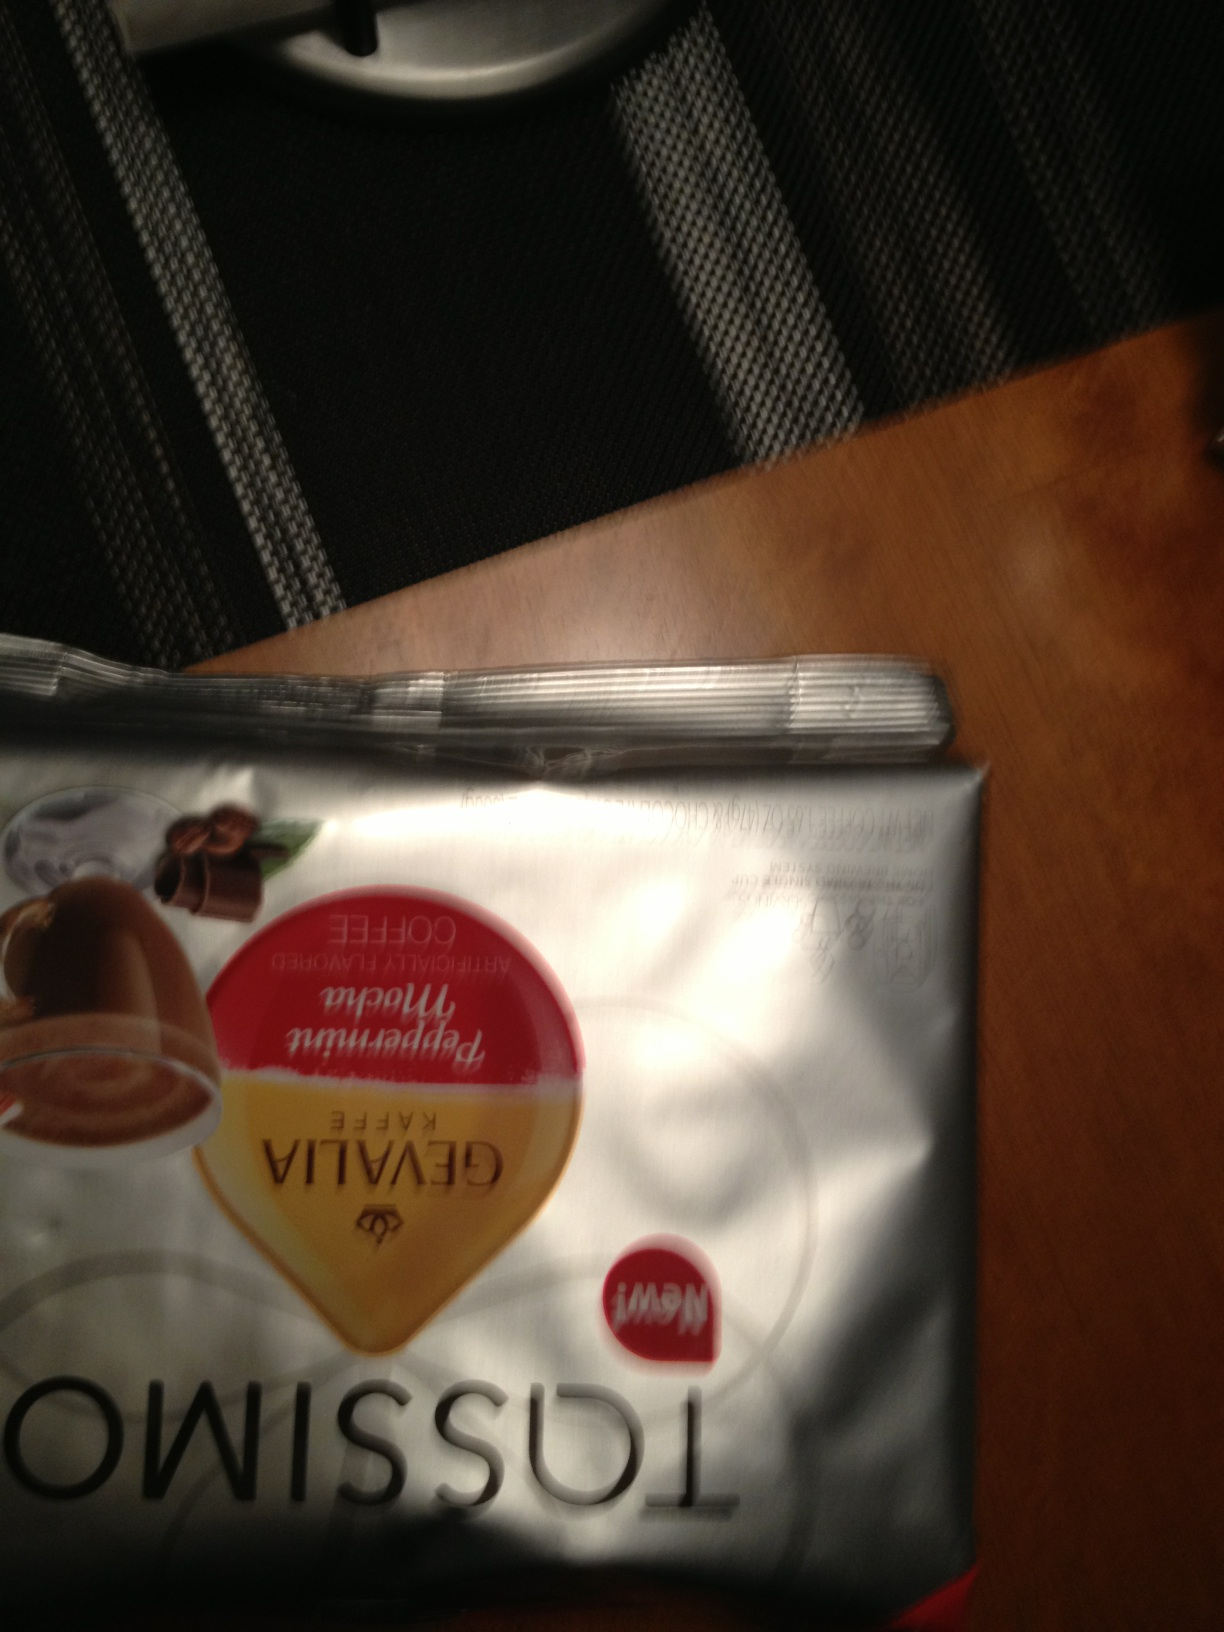What kind of coffee is this? The coffee in the image appears to be Gevalia Kaffe, a premium coffee brand known for its rich, smooth taste. The packaging suggests that it is likely a variety intended for making a specific type of coffee beverage, possibly a latte or cappuccino, as indicated by the imagery on the bag. 